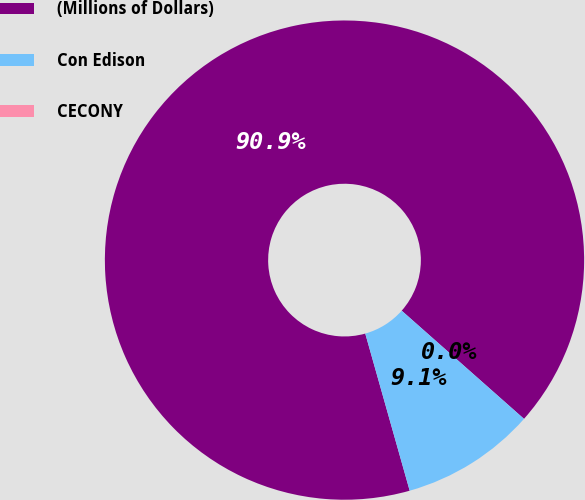<chart> <loc_0><loc_0><loc_500><loc_500><pie_chart><fcel>(Millions of Dollars)<fcel>Con Edison<fcel>CECONY<nl><fcel>90.91%<fcel>9.09%<fcel>0.0%<nl></chart> 